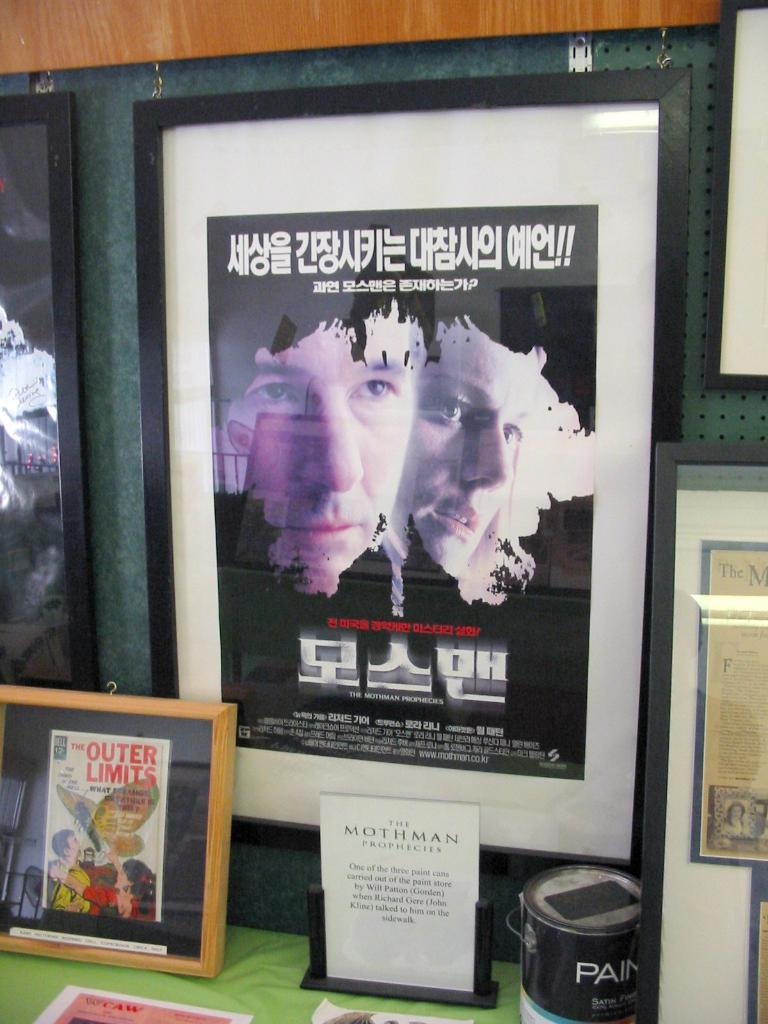<image>
Present a compact description of the photo's key features. A display of framed collectibles, including something from the Outer Limits. 